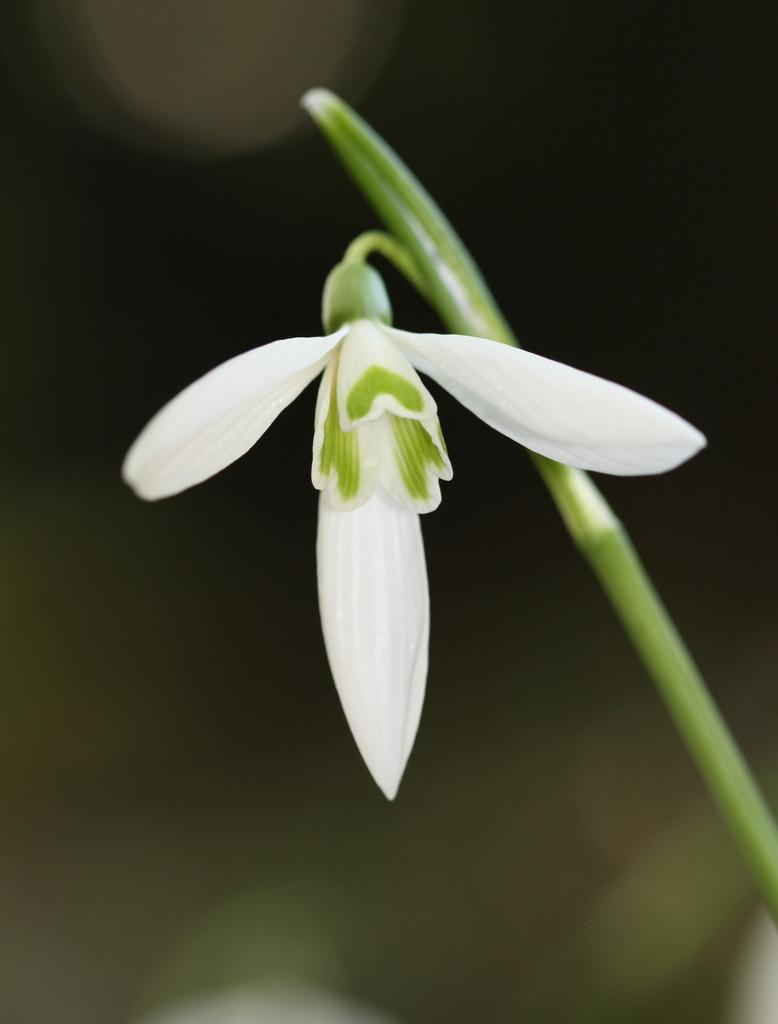What is present in the image? There is a flower in the image. Can you describe the flower in more detail? The flower has a stem. What type of expansion is the flower undergoing in the image? The flower is not undergoing any expansion in the image; it is a static image of a flower with a stem. Is there a notebook visible in the image? No, there is no notebook present in the image. 